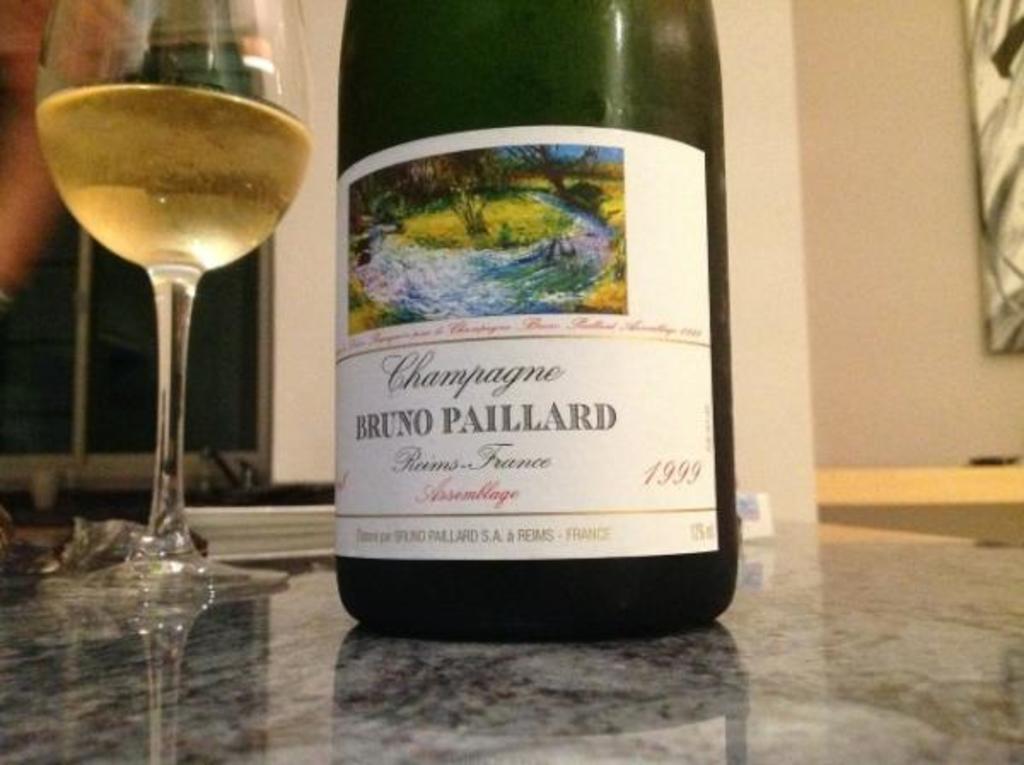What year was this champagne bottled?
Give a very brief answer. 1999. What is the brand of this bottle?
Offer a very short reply. Bruno paillard. 